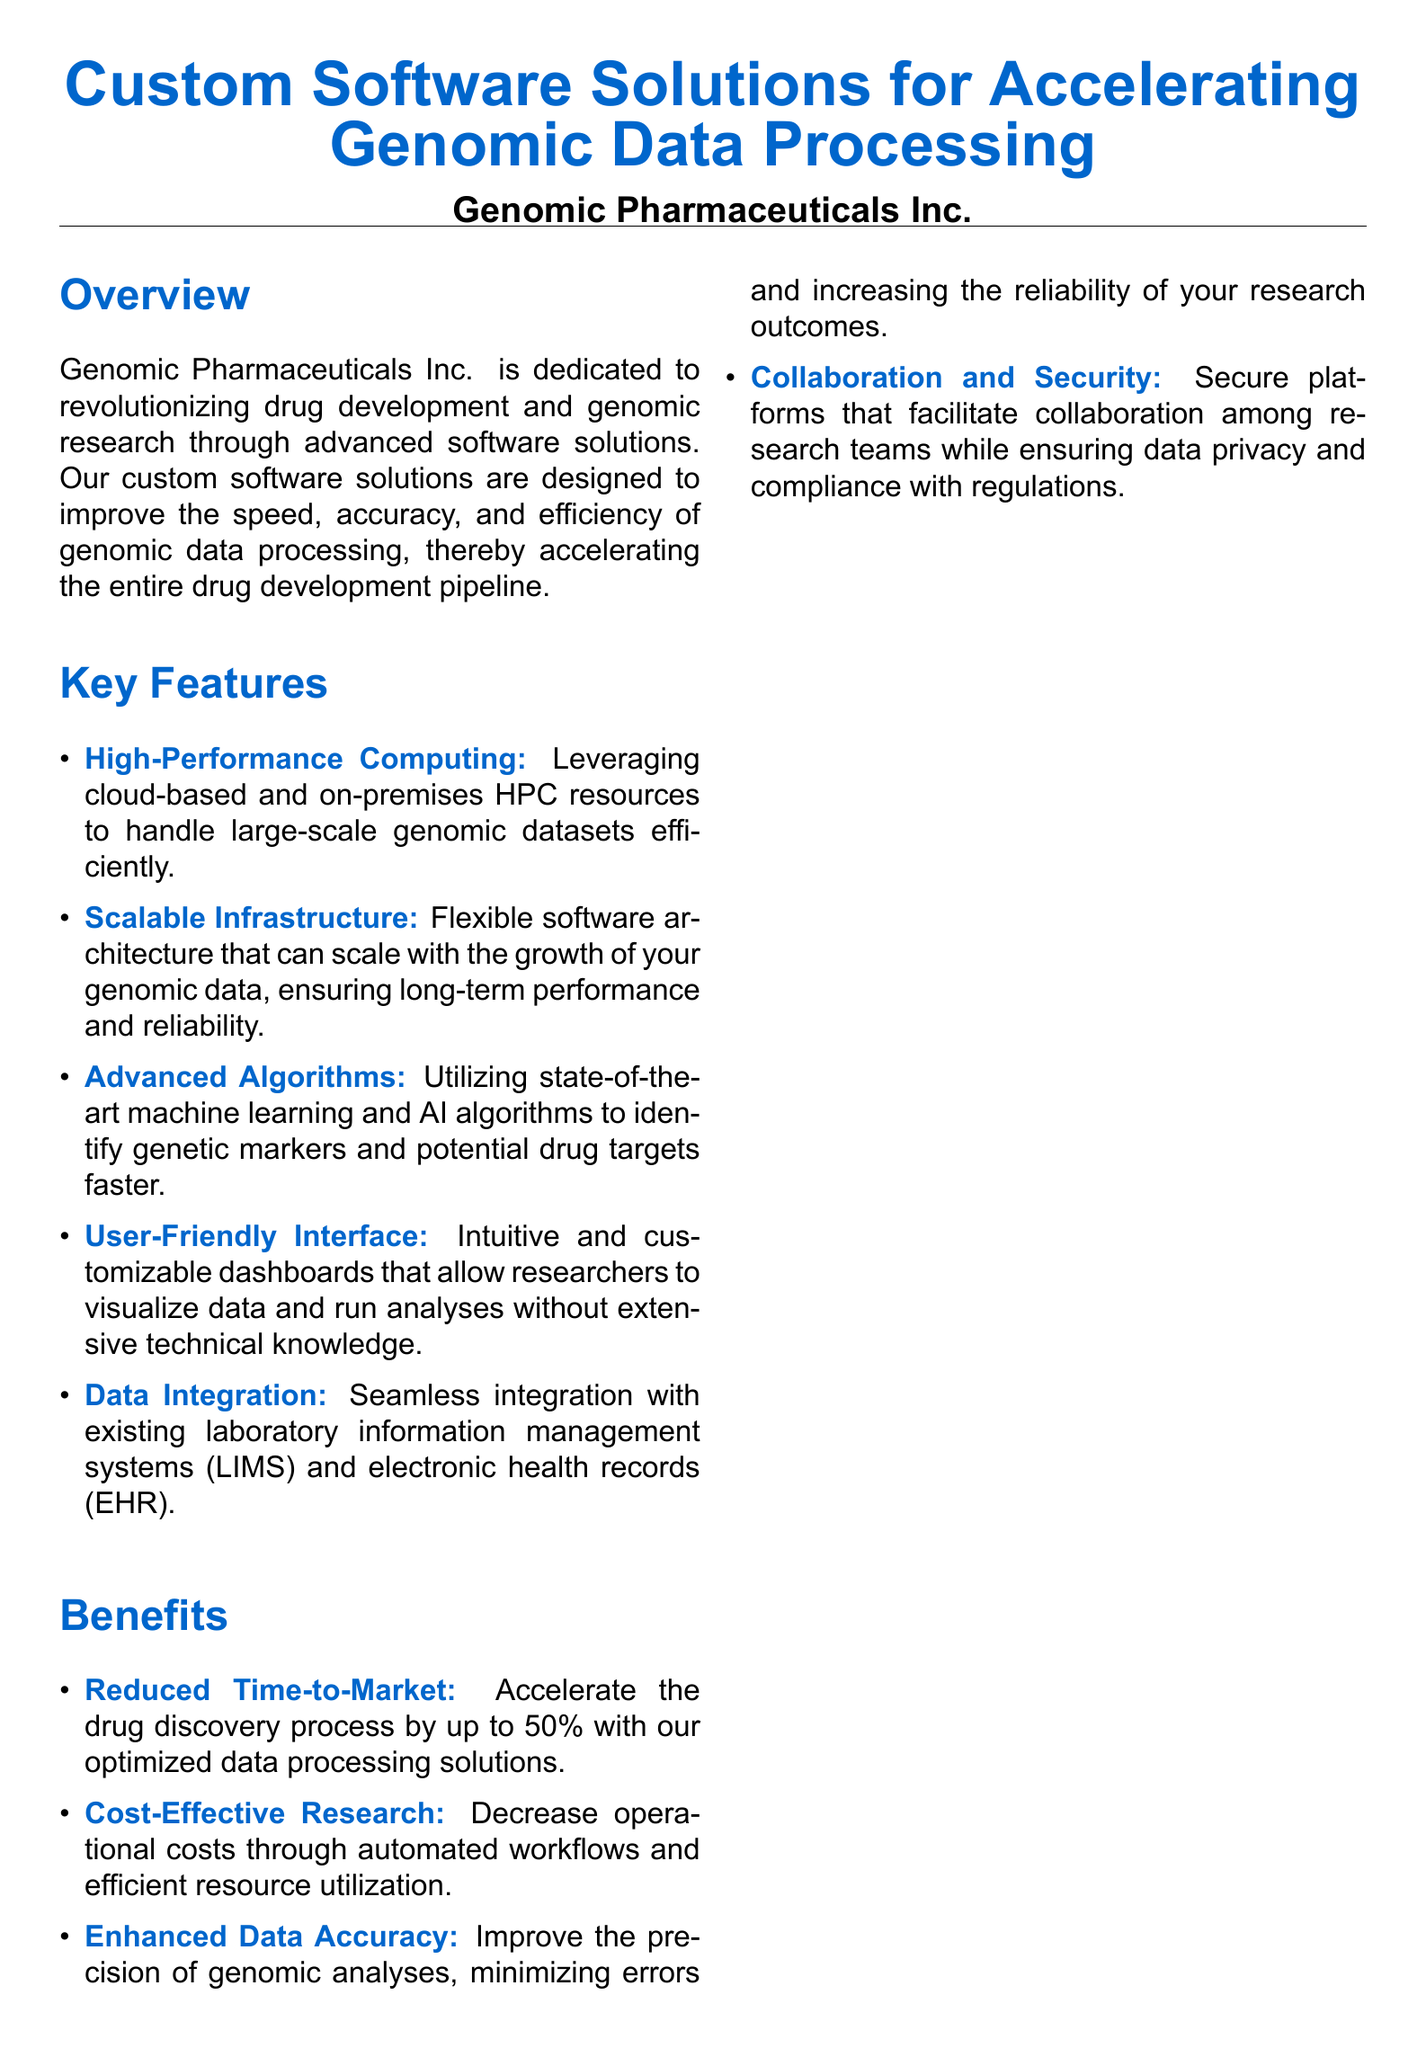What company is offering the software solutions? The document identifies Genomic Pharmaceuticals Inc. as the company providing the solutions.
Answer: Genomic Pharmaceuticals Inc What feature allows for handling large-scale datasets efficiently? The document mentions High-Performance Computing as a key feature for this purpose.
Answer: High-Performance Computing What is the expected reduction in time-to-market? The document states that the solutions can accelerate the drug discovery process by up to 50%.
Answer: 50% What type of algorithms are utilized in the software solutions? The document specifies that Advanced Algorithms, particularly machine learning and AI algorithms, are utilized.
Answer: Advanced Algorithms What was the result of the case study with XYZ Genomics? The case study indicates a 40% reduction in data processing time as a result of implementing the software solution.
Answer: 40% How can researchers visualize data according to the document? The document mentions a User-Friendly Interface that provides intuitive and customizable dashboards for data visualization.
Answer: User-Friendly Interface What is one of the benefits listed regarding operational costs? The document states that the software solutions help decrease operational costs through automated workflows.
Answer: Cost-Effective Research Where can potential clients contact the company? The document provides an email address for contact, which is listed as contact@genomicpharma.com.
Answer: contact@genomicpharma.com 